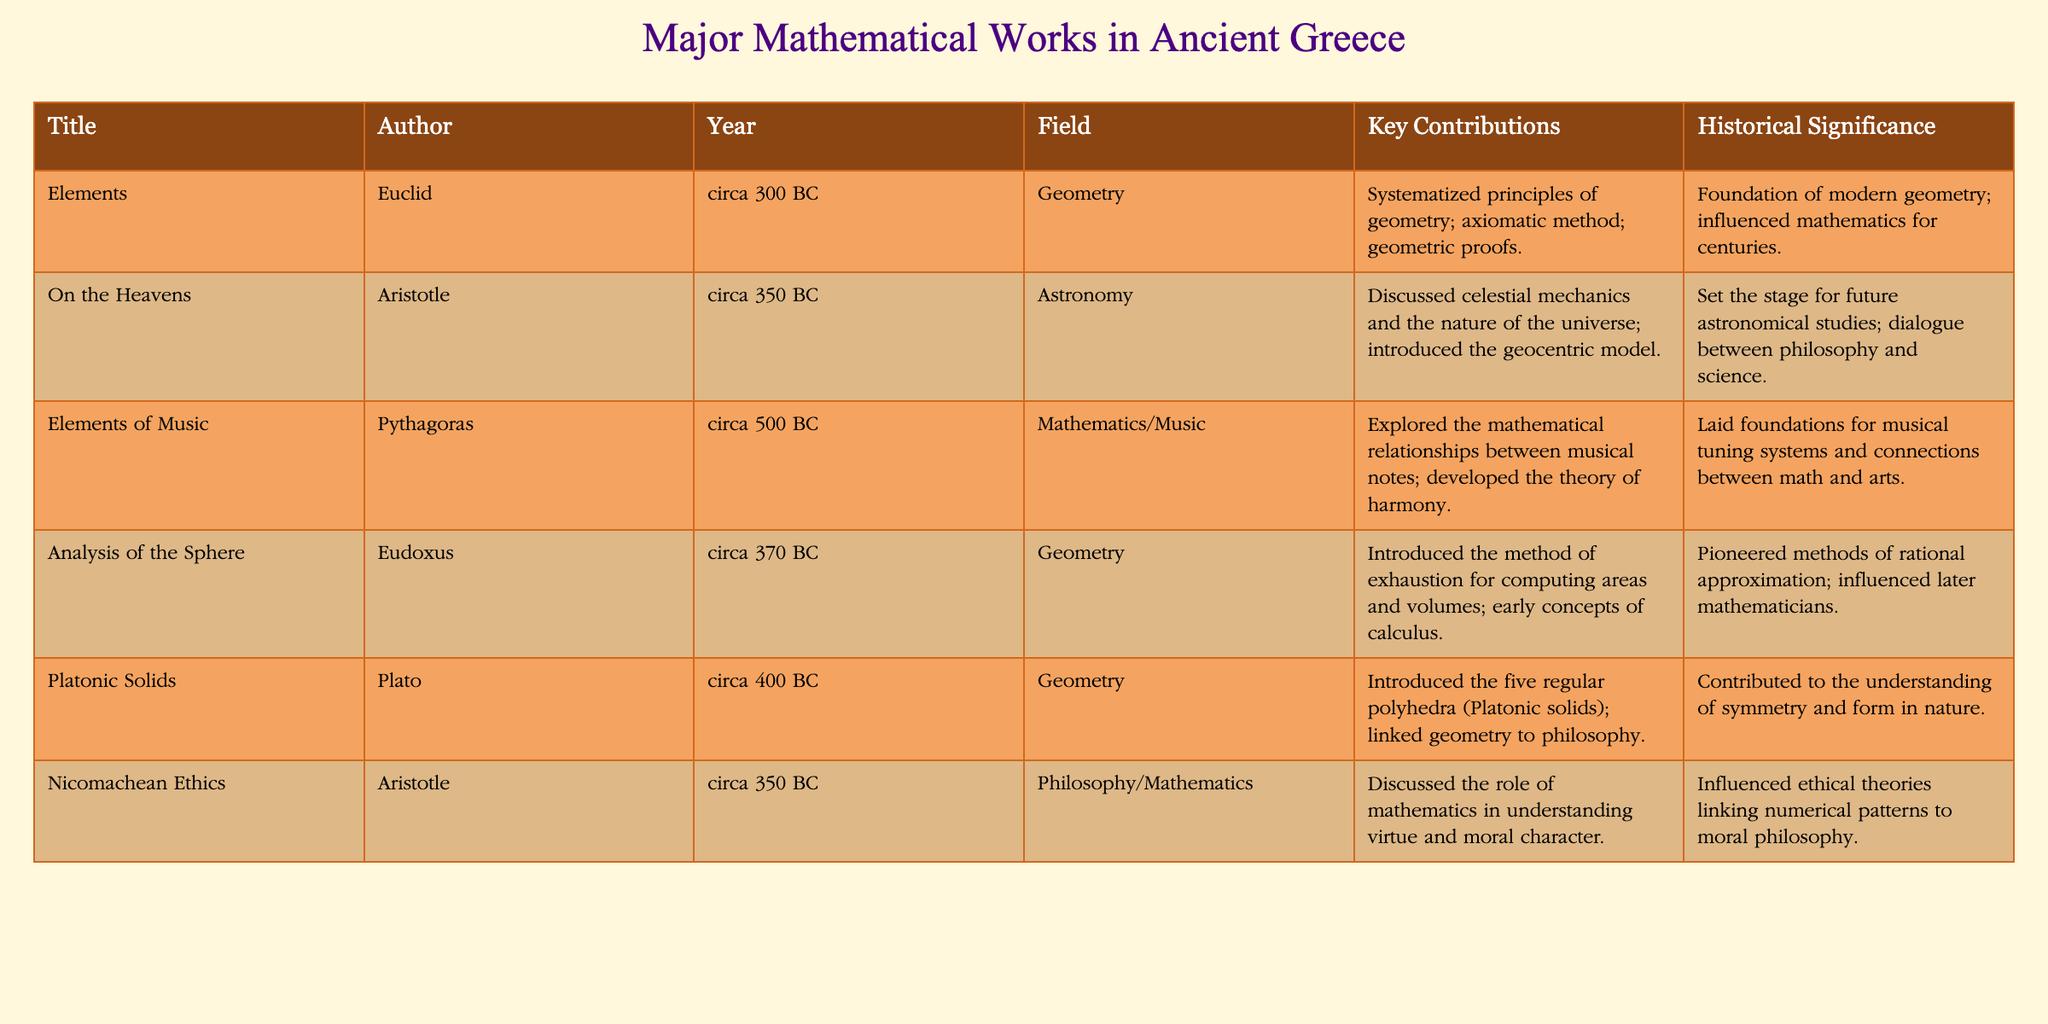What is the title of the work authored by Euclid? The table states that Euclid authored the work titled "Elements."
Answer: "Elements" Which work discusses the nature of the universe and who is its author? The table lists "On the Heavens" as the work discussing the nature of the universe, authored by Aristotle.
Answer: "On the Heavens" by Aristotle How many years before Christ was "Elements of Music" written? "Elements of Music" by Pythagoras was written around 500 BC, and since the year 1 AD is the starting point for the Anno Domini system, it was written 500 years before Christ.
Answer: 500 years Did Plato contribute to the field of Astronomy? According to the table, Plato's contributions are listed under Geometry, not Astronomy; therefore, the answer is no.
Answer: No Which work has historical significance linked to ethical theories? The "Nicomachean Ethics" by Aristotle is mentioned in the table as having influenced ethical theories linking numerical patterns to moral philosophy.
Answer: "Nicomachean Ethics" What is the average year of publication of the works listed in the table? The years of publication are circa 500 BC, 400 BC, 370 BC, 350 BC (twice), and 300 BC. In total, that sums to 1870 years before Christ. There are 6 works, so the average is 1870/6, which approximately equals 311.67 years before Christ.
Answer: 311.67 years before Christ Which two authors worked on geometry? The table shows that both Euclid and Eudoxus authored works in the field of Geometry.
Answer: Euclid and Eudoxus What was the key contribution of Aristotle in his work "Nicomachean Ethics"? The table indicates that Aristotle discussed the role of mathematics in understanding virtue and moral character in "Nicomachean Ethics."
Answer: Understanding virtue and moral character What is the historical significance of the work "Elements"? The historical significance listed in the table for "Elements" is that it served as the foundation of modern geometry and influenced mathematics for centuries.
Answer: Foundation of modern geometry; influenced mathematics for centuries 